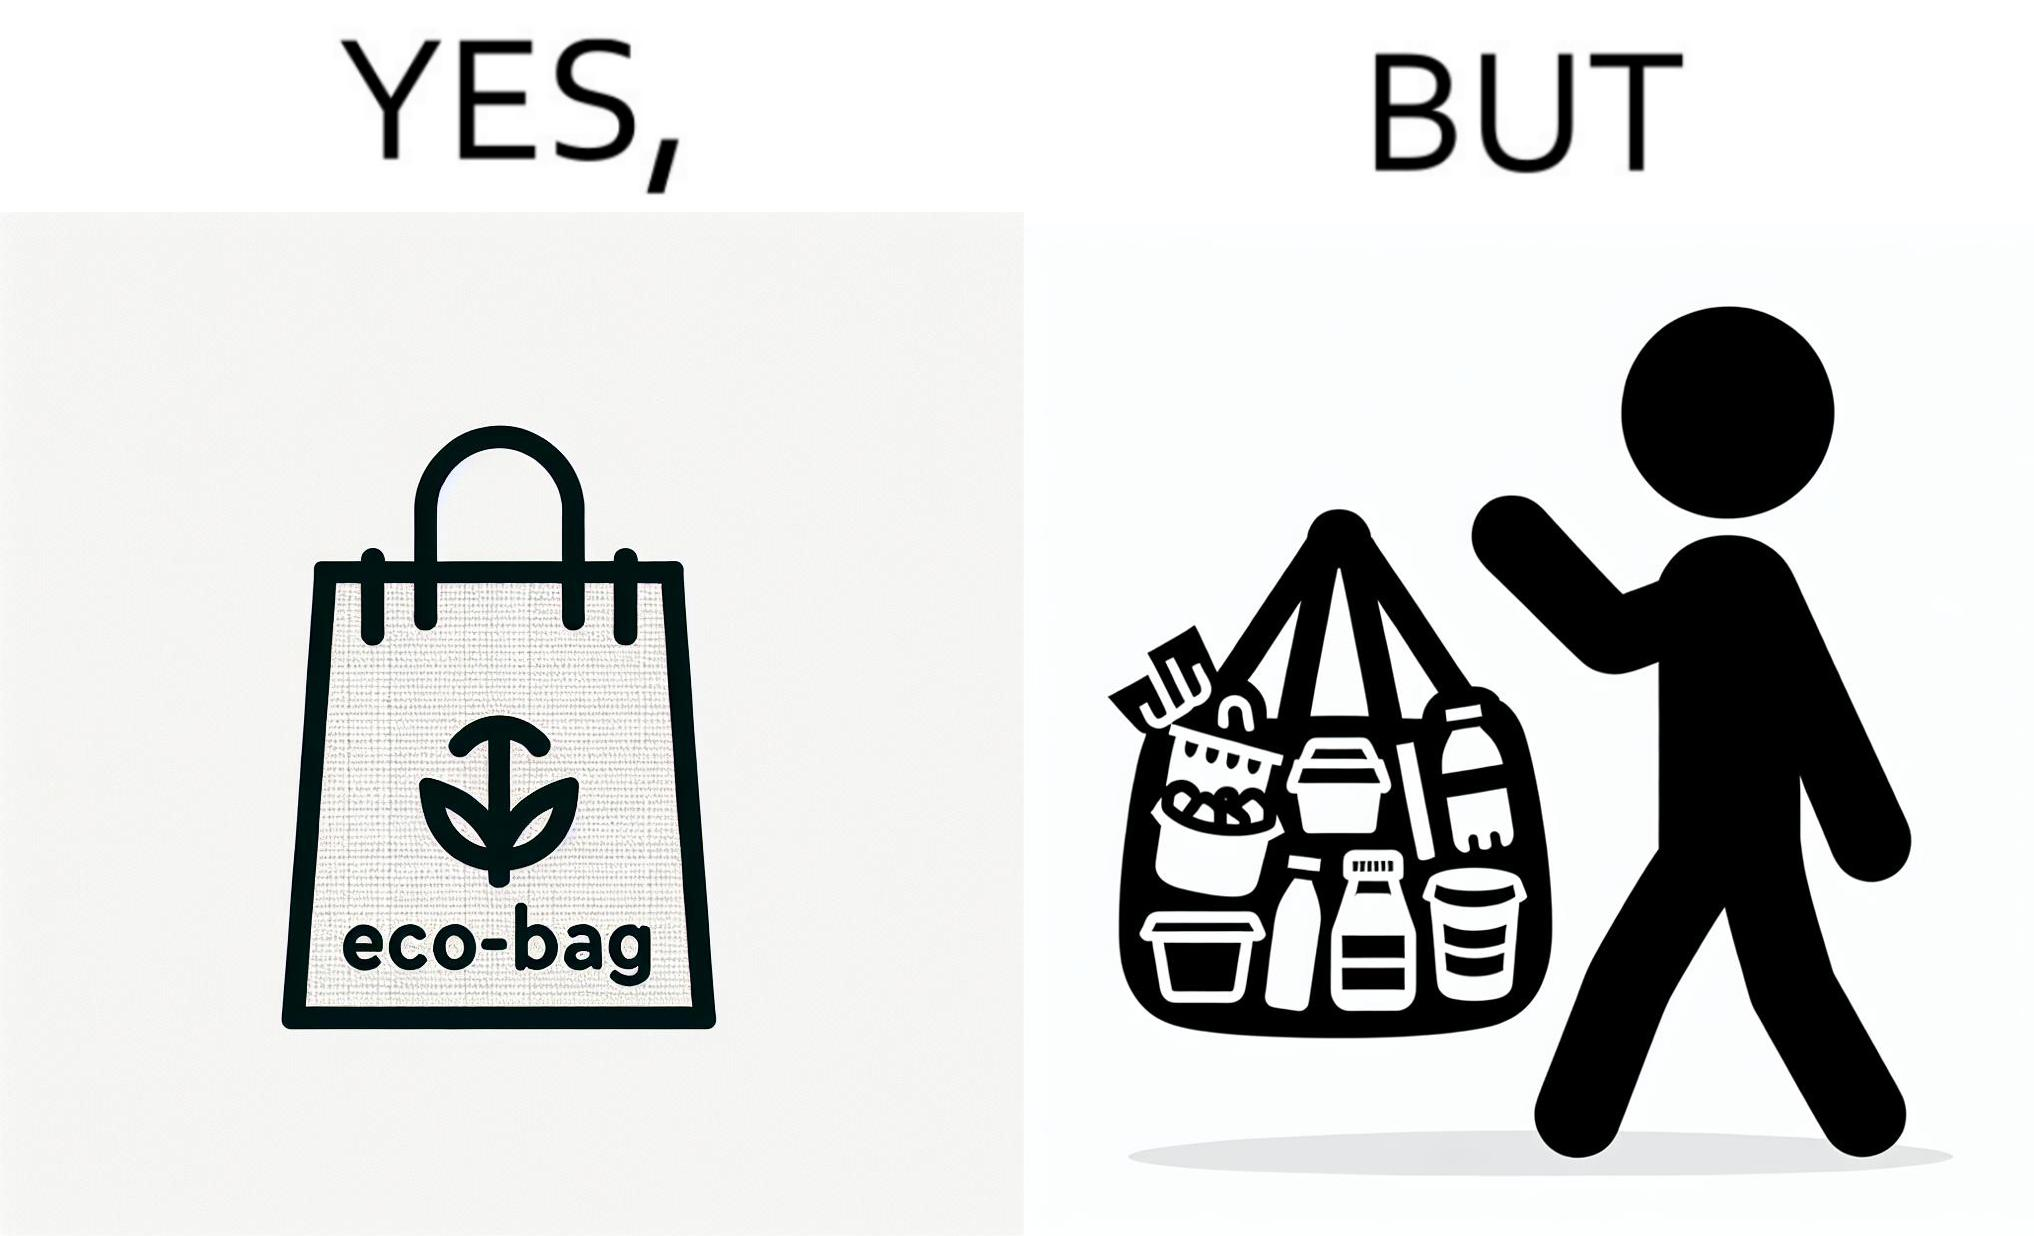What makes this image funny or satirical? The image is ironic, because people nowadays use eco-bag thinking them as safe for the environment but in turn use products which are harmful for the environment or are packaged in some non-biodegradable material 